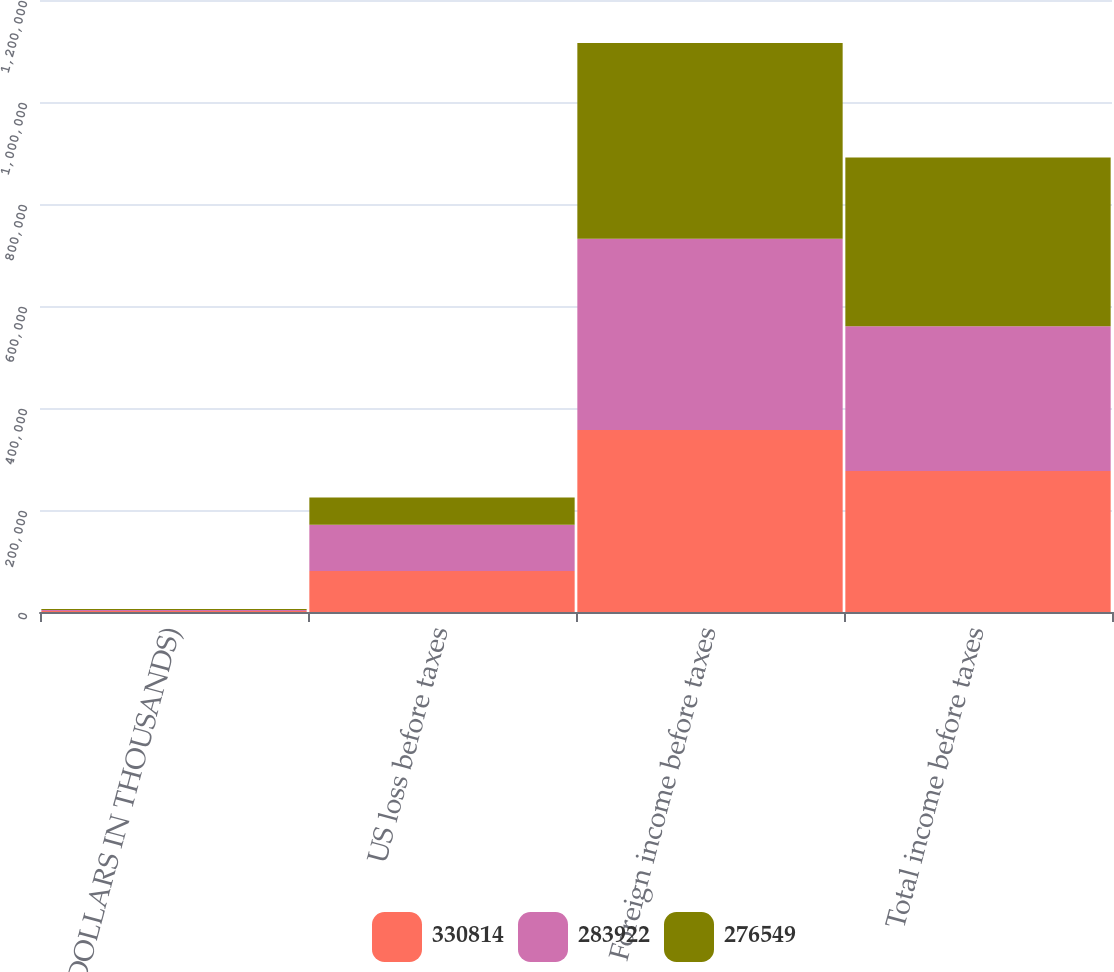Convert chart. <chart><loc_0><loc_0><loc_500><loc_500><stacked_bar_chart><ecel><fcel>(DOLLARS IN THOUSANDS)<fcel>US loss before taxes<fcel>Foreign income before taxes<fcel>Total income before taxes<nl><fcel>330814<fcel>2009<fcel>80345<fcel>356894<fcel>276549<nl><fcel>283922<fcel>2008<fcel>90819<fcel>374741<fcel>283922<nl><fcel>276549<fcel>2007<fcel>53159<fcel>383973<fcel>330814<nl></chart> 